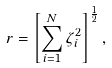<formula> <loc_0><loc_0><loc_500><loc_500>r = \left [ \sum _ { i = 1 } ^ { N } \zeta _ { i } ^ { 2 } \right ] ^ { \frac { 1 } { 2 } } ,</formula> 